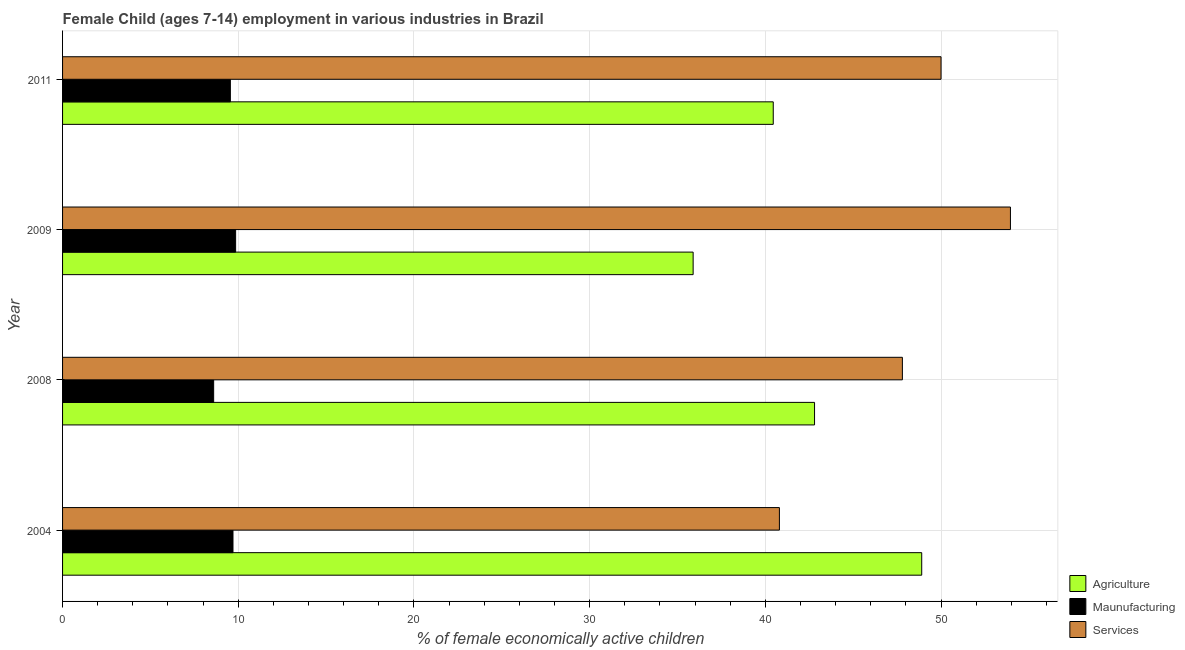How many different coloured bars are there?
Provide a succinct answer. 3. Are the number of bars per tick equal to the number of legend labels?
Offer a very short reply. Yes. Are the number of bars on each tick of the Y-axis equal?
Keep it short and to the point. Yes. In how many cases, is the number of bars for a given year not equal to the number of legend labels?
Offer a terse response. 0. What is the percentage of economically active children in manufacturing in 2004?
Offer a very short reply. 9.7. Across all years, what is the maximum percentage of economically active children in manufacturing?
Offer a terse response. 9.85. Across all years, what is the minimum percentage of economically active children in services?
Make the answer very short. 40.8. What is the total percentage of economically active children in services in the graph?
Your answer should be compact. 192.55. What is the difference between the percentage of economically active children in manufacturing in 2004 and that in 2009?
Give a very brief answer. -0.15. What is the difference between the percentage of economically active children in services in 2009 and the percentage of economically active children in agriculture in 2008?
Offer a very short reply. 11.15. What is the average percentage of economically active children in services per year?
Your response must be concise. 48.14. What is the ratio of the percentage of economically active children in manufacturing in 2004 to that in 2008?
Provide a succinct answer. 1.13. What is the difference between the highest and the lowest percentage of economically active children in agriculture?
Offer a very short reply. 13.01. Is the sum of the percentage of economically active children in services in 2004 and 2009 greater than the maximum percentage of economically active children in agriculture across all years?
Your answer should be very brief. Yes. What does the 1st bar from the top in 2008 represents?
Offer a terse response. Services. What does the 1st bar from the bottom in 2011 represents?
Provide a short and direct response. Agriculture. How many bars are there?
Make the answer very short. 12. What is the difference between two consecutive major ticks on the X-axis?
Offer a terse response. 10. Does the graph contain any zero values?
Make the answer very short. No. Where does the legend appear in the graph?
Your answer should be very brief. Bottom right. How many legend labels are there?
Ensure brevity in your answer.  3. What is the title of the graph?
Give a very brief answer. Female Child (ages 7-14) employment in various industries in Brazil. Does "Transport services" appear as one of the legend labels in the graph?
Your response must be concise. No. What is the label or title of the X-axis?
Give a very brief answer. % of female economically active children. What is the % of female economically active children in Agriculture in 2004?
Your answer should be compact. 48.9. What is the % of female economically active children in Services in 2004?
Ensure brevity in your answer.  40.8. What is the % of female economically active children of Agriculture in 2008?
Your response must be concise. 42.8. What is the % of female economically active children in Services in 2008?
Keep it short and to the point. 47.8. What is the % of female economically active children of Agriculture in 2009?
Provide a short and direct response. 35.89. What is the % of female economically active children of Maunufacturing in 2009?
Your answer should be compact. 9.85. What is the % of female economically active children in Services in 2009?
Your response must be concise. 53.95. What is the % of female economically active children of Agriculture in 2011?
Offer a very short reply. 40.45. What is the % of female economically active children of Maunufacturing in 2011?
Provide a short and direct response. 9.55. What is the % of female economically active children of Services in 2011?
Your response must be concise. 50. Across all years, what is the maximum % of female economically active children of Agriculture?
Offer a very short reply. 48.9. Across all years, what is the maximum % of female economically active children in Maunufacturing?
Ensure brevity in your answer.  9.85. Across all years, what is the maximum % of female economically active children of Services?
Offer a terse response. 53.95. Across all years, what is the minimum % of female economically active children of Agriculture?
Ensure brevity in your answer.  35.89. Across all years, what is the minimum % of female economically active children of Services?
Provide a succinct answer. 40.8. What is the total % of female economically active children in Agriculture in the graph?
Provide a short and direct response. 168.04. What is the total % of female economically active children in Maunufacturing in the graph?
Ensure brevity in your answer.  37.7. What is the total % of female economically active children of Services in the graph?
Offer a very short reply. 192.55. What is the difference between the % of female economically active children of Agriculture in 2004 and that in 2008?
Your response must be concise. 6.1. What is the difference between the % of female economically active children of Agriculture in 2004 and that in 2009?
Provide a short and direct response. 13.01. What is the difference between the % of female economically active children in Maunufacturing in 2004 and that in 2009?
Your answer should be very brief. -0.15. What is the difference between the % of female economically active children in Services in 2004 and that in 2009?
Your answer should be very brief. -13.15. What is the difference between the % of female economically active children of Agriculture in 2004 and that in 2011?
Keep it short and to the point. 8.45. What is the difference between the % of female economically active children in Agriculture in 2008 and that in 2009?
Your response must be concise. 6.91. What is the difference between the % of female economically active children in Maunufacturing in 2008 and that in 2009?
Ensure brevity in your answer.  -1.25. What is the difference between the % of female economically active children of Services in 2008 and that in 2009?
Provide a succinct answer. -6.15. What is the difference between the % of female economically active children of Agriculture in 2008 and that in 2011?
Ensure brevity in your answer.  2.35. What is the difference between the % of female economically active children of Maunufacturing in 2008 and that in 2011?
Your answer should be compact. -0.95. What is the difference between the % of female economically active children in Agriculture in 2009 and that in 2011?
Your answer should be compact. -4.56. What is the difference between the % of female economically active children in Services in 2009 and that in 2011?
Keep it short and to the point. 3.95. What is the difference between the % of female economically active children of Agriculture in 2004 and the % of female economically active children of Maunufacturing in 2008?
Offer a very short reply. 40.3. What is the difference between the % of female economically active children in Agriculture in 2004 and the % of female economically active children in Services in 2008?
Offer a terse response. 1.1. What is the difference between the % of female economically active children in Maunufacturing in 2004 and the % of female economically active children in Services in 2008?
Your response must be concise. -38.1. What is the difference between the % of female economically active children of Agriculture in 2004 and the % of female economically active children of Maunufacturing in 2009?
Provide a short and direct response. 39.05. What is the difference between the % of female economically active children in Agriculture in 2004 and the % of female economically active children in Services in 2009?
Give a very brief answer. -5.05. What is the difference between the % of female economically active children of Maunufacturing in 2004 and the % of female economically active children of Services in 2009?
Your response must be concise. -44.25. What is the difference between the % of female economically active children of Agriculture in 2004 and the % of female economically active children of Maunufacturing in 2011?
Make the answer very short. 39.35. What is the difference between the % of female economically active children of Maunufacturing in 2004 and the % of female economically active children of Services in 2011?
Your response must be concise. -40.3. What is the difference between the % of female economically active children of Agriculture in 2008 and the % of female economically active children of Maunufacturing in 2009?
Give a very brief answer. 32.95. What is the difference between the % of female economically active children of Agriculture in 2008 and the % of female economically active children of Services in 2009?
Your answer should be very brief. -11.15. What is the difference between the % of female economically active children of Maunufacturing in 2008 and the % of female economically active children of Services in 2009?
Give a very brief answer. -45.35. What is the difference between the % of female economically active children of Agriculture in 2008 and the % of female economically active children of Maunufacturing in 2011?
Offer a very short reply. 33.25. What is the difference between the % of female economically active children in Maunufacturing in 2008 and the % of female economically active children in Services in 2011?
Offer a very short reply. -41.4. What is the difference between the % of female economically active children in Agriculture in 2009 and the % of female economically active children in Maunufacturing in 2011?
Keep it short and to the point. 26.34. What is the difference between the % of female economically active children in Agriculture in 2009 and the % of female economically active children in Services in 2011?
Offer a very short reply. -14.11. What is the difference between the % of female economically active children in Maunufacturing in 2009 and the % of female economically active children in Services in 2011?
Make the answer very short. -40.15. What is the average % of female economically active children in Agriculture per year?
Ensure brevity in your answer.  42.01. What is the average % of female economically active children in Maunufacturing per year?
Provide a short and direct response. 9.43. What is the average % of female economically active children in Services per year?
Offer a very short reply. 48.14. In the year 2004, what is the difference between the % of female economically active children in Agriculture and % of female economically active children in Maunufacturing?
Keep it short and to the point. 39.2. In the year 2004, what is the difference between the % of female economically active children in Agriculture and % of female economically active children in Services?
Ensure brevity in your answer.  8.1. In the year 2004, what is the difference between the % of female economically active children of Maunufacturing and % of female economically active children of Services?
Offer a terse response. -31.1. In the year 2008, what is the difference between the % of female economically active children in Agriculture and % of female economically active children in Maunufacturing?
Ensure brevity in your answer.  34.2. In the year 2008, what is the difference between the % of female economically active children of Agriculture and % of female economically active children of Services?
Your response must be concise. -5. In the year 2008, what is the difference between the % of female economically active children in Maunufacturing and % of female economically active children in Services?
Your answer should be very brief. -39.2. In the year 2009, what is the difference between the % of female economically active children in Agriculture and % of female economically active children in Maunufacturing?
Offer a terse response. 26.04. In the year 2009, what is the difference between the % of female economically active children of Agriculture and % of female economically active children of Services?
Provide a short and direct response. -18.06. In the year 2009, what is the difference between the % of female economically active children in Maunufacturing and % of female economically active children in Services?
Give a very brief answer. -44.1. In the year 2011, what is the difference between the % of female economically active children in Agriculture and % of female economically active children in Maunufacturing?
Your response must be concise. 30.9. In the year 2011, what is the difference between the % of female economically active children in Agriculture and % of female economically active children in Services?
Your answer should be very brief. -9.55. In the year 2011, what is the difference between the % of female economically active children in Maunufacturing and % of female economically active children in Services?
Offer a very short reply. -40.45. What is the ratio of the % of female economically active children of Agriculture in 2004 to that in 2008?
Provide a succinct answer. 1.14. What is the ratio of the % of female economically active children in Maunufacturing in 2004 to that in 2008?
Make the answer very short. 1.13. What is the ratio of the % of female economically active children in Services in 2004 to that in 2008?
Ensure brevity in your answer.  0.85. What is the ratio of the % of female economically active children in Agriculture in 2004 to that in 2009?
Ensure brevity in your answer.  1.36. What is the ratio of the % of female economically active children in Maunufacturing in 2004 to that in 2009?
Provide a short and direct response. 0.98. What is the ratio of the % of female economically active children in Services in 2004 to that in 2009?
Offer a very short reply. 0.76. What is the ratio of the % of female economically active children of Agriculture in 2004 to that in 2011?
Offer a terse response. 1.21. What is the ratio of the % of female economically active children in Maunufacturing in 2004 to that in 2011?
Give a very brief answer. 1.02. What is the ratio of the % of female economically active children of Services in 2004 to that in 2011?
Your answer should be compact. 0.82. What is the ratio of the % of female economically active children in Agriculture in 2008 to that in 2009?
Give a very brief answer. 1.19. What is the ratio of the % of female economically active children in Maunufacturing in 2008 to that in 2009?
Keep it short and to the point. 0.87. What is the ratio of the % of female economically active children of Services in 2008 to that in 2009?
Ensure brevity in your answer.  0.89. What is the ratio of the % of female economically active children of Agriculture in 2008 to that in 2011?
Give a very brief answer. 1.06. What is the ratio of the % of female economically active children in Maunufacturing in 2008 to that in 2011?
Give a very brief answer. 0.9. What is the ratio of the % of female economically active children of Services in 2008 to that in 2011?
Offer a very short reply. 0.96. What is the ratio of the % of female economically active children in Agriculture in 2009 to that in 2011?
Offer a very short reply. 0.89. What is the ratio of the % of female economically active children in Maunufacturing in 2009 to that in 2011?
Offer a terse response. 1.03. What is the ratio of the % of female economically active children of Services in 2009 to that in 2011?
Your answer should be very brief. 1.08. What is the difference between the highest and the second highest % of female economically active children of Agriculture?
Provide a succinct answer. 6.1. What is the difference between the highest and the second highest % of female economically active children in Services?
Provide a short and direct response. 3.95. What is the difference between the highest and the lowest % of female economically active children of Agriculture?
Your answer should be compact. 13.01. What is the difference between the highest and the lowest % of female economically active children of Services?
Make the answer very short. 13.15. 